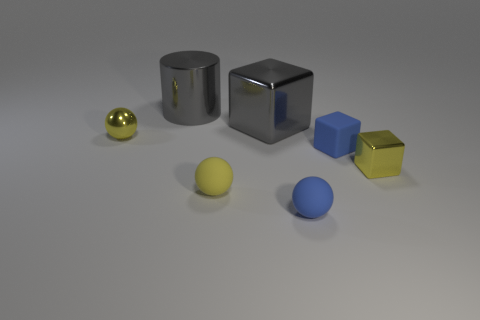What number of blue rubber spheres are on the right side of the large metallic object in front of the gray object that is behind the large cube?
Provide a succinct answer. 1. The blue rubber thing that is the same shape as the tiny yellow matte object is what size?
Your answer should be very brief. Small. Are there any other things that have the same size as the yellow shiny ball?
Keep it short and to the point. Yes. Does the tiny yellow sphere in front of the small shiny ball have the same material as the blue ball?
Give a very brief answer. Yes. What color is the tiny shiny object that is the same shape as the yellow rubber object?
Provide a short and direct response. Yellow. How many other objects are the same color as the small shiny sphere?
Offer a terse response. 2. Is the shape of the tiny blue matte thing that is in front of the yellow block the same as the tiny object that is behind the rubber block?
Provide a short and direct response. Yes. What number of spheres are either tiny yellow shiny things or big objects?
Provide a short and direct response. 1. Is the number of blue matte cubes that are to the left of the gray cube less than the number of gray objects?
Your response must be concise. Yes. What number of other things are made of the same material as the cylinder?
Your answer should be very brief. 3. 